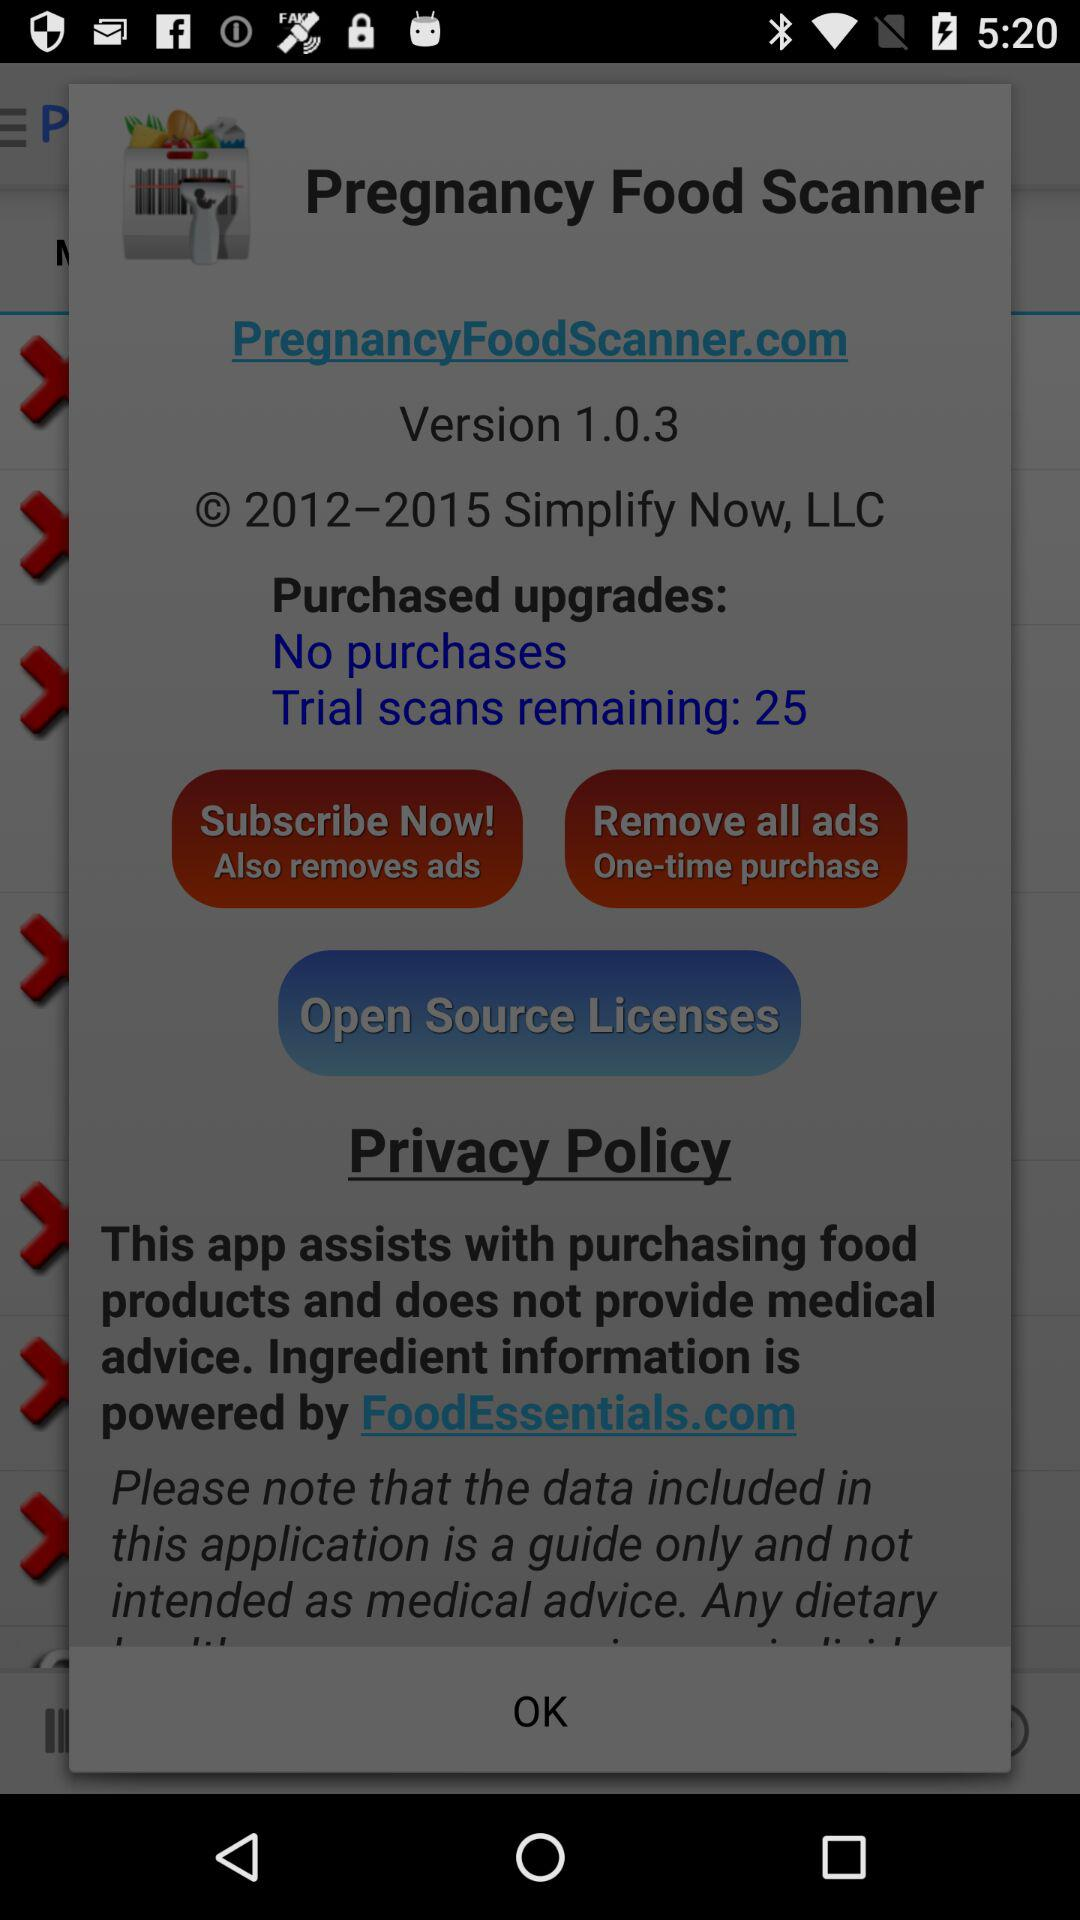How many more trial scans are remaining than purchased upgrades?
Answer the question using a single word or phrase. 25 